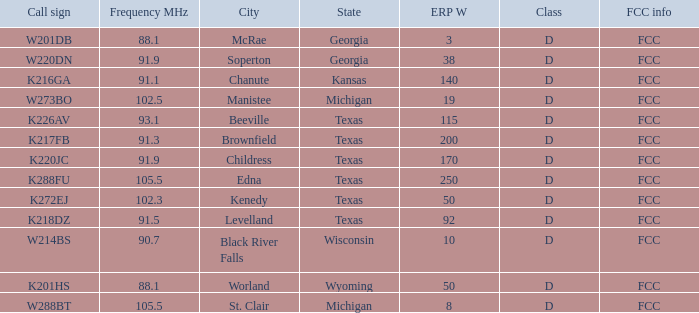What is City of License, when Frequency MHz is less than 102.5? McRae, Georgia, Soperton, Georgia, Chanute, Kansas, Beeville, Texas, Brownfield, Texas, Childress, Texas, Kenedy, Texas, Levelland, Texas, Black River Falls, Wisconsin, Worland, Wyoming. 